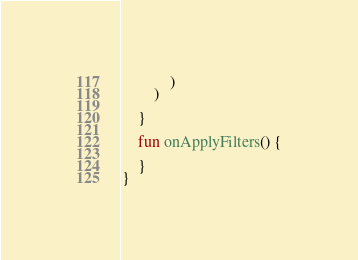Convert code to text. <code><loc_0><loc_0><loc_500><loc_500><_Kotlin_>            )
        )

    }

    fun onApplyFilters() {

    }
}</code> 